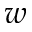<formula> <loc_0><loc_0><loc_500><loc_500>w</formula> 